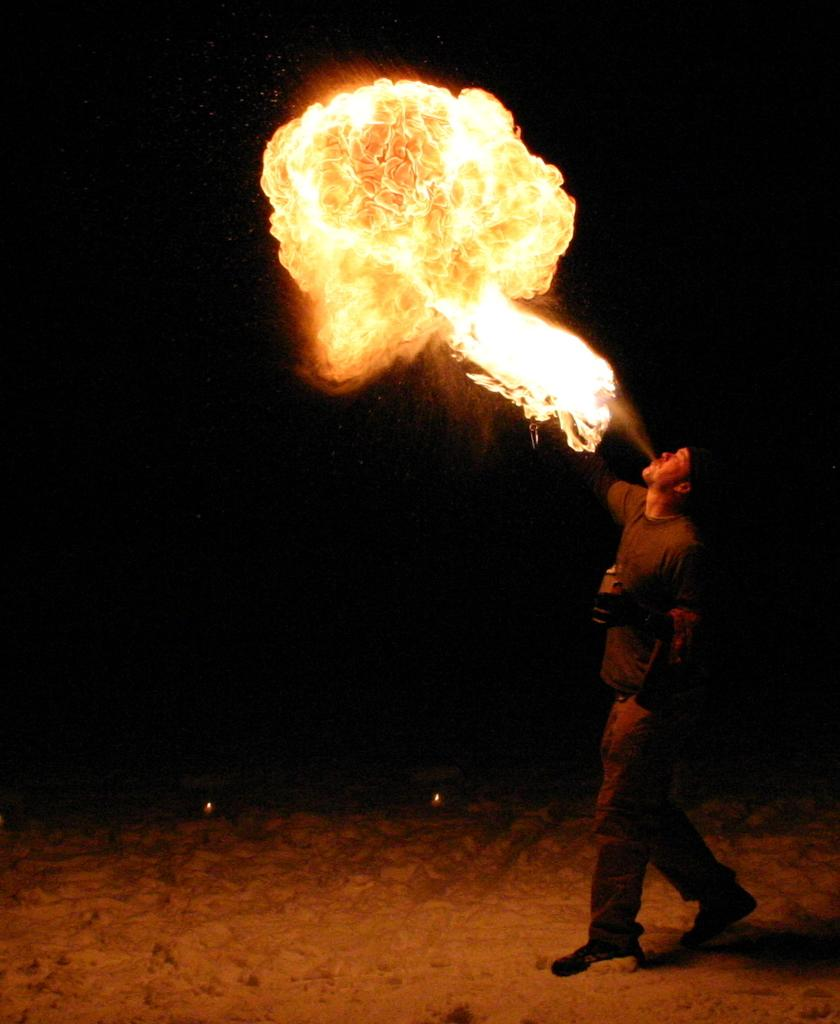Who is the main subject in the image? There is a man in the image. Where is the man located in the image? The man is on the right side of the image. What is the man doing in the image? The man is blowing fire. What type of development is taking place in the image? There is no development project or construction site present in the image; it features a man blowing fire. Is the man playing volleyball in the image? No, the man is not playing volleyball in the image; he is blowing fire. 